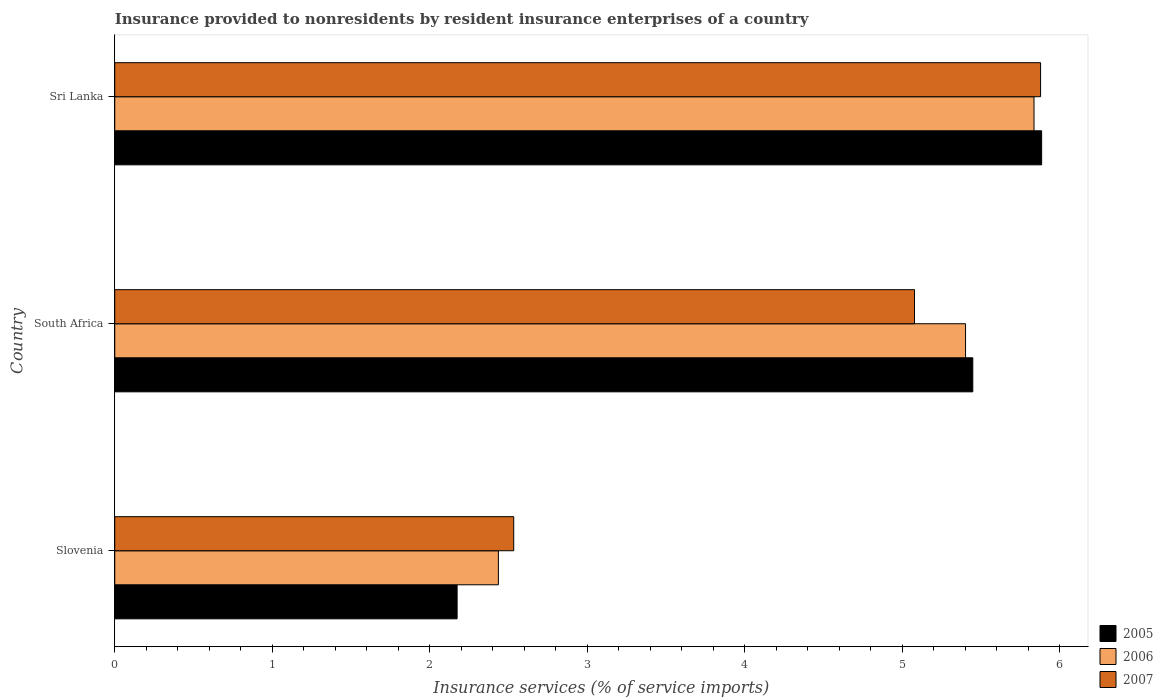How many different coloured bars are there?
Offer a very short reply. 3. Are the number of bars on each tick of the Y-axis equal?
Your answer should be compact. Yes. How many bars are there on the 2nd tick from the top?
Ensure brevity in your answer.  3. What is the label of the 1st group of bars from the top?
Offer a very short reply. Sri Lanka. In how many cases, is the number of bars for a given country not equal to the number of legend labels?
Give a very brief answer. 0. What is the insurance provided to nonresidents in 2005 in Slovenia?
Your response must be concise. 2.17. Across all countries, what is the maximum insurance provided to nonresidents in 2005?
Ensure brevity in your answer.  5.89. Across all countries, what is the minimum insurance provided to nonresidents in 2005?
Provide a succinct answer. 2.17. In which country was the insurance provided to nonresidents in 2006 maximum?
Your answer should be very brief. Sri Lanka. In which country was the insurance provided to nonresidents in 2006 minimum?
Provide a short and direct response. Slovenia. What is the total insurance provided to nonresidents in 2006 in the graph?
Your response must be concise. 13.68. What is the difference between the insurance provided to nonresidents in 2005 in Slovenia and that in South Africa?
Give a very brief answer. -3.27. What is the difference between the insurance provided to nonresidents in 2005 in Sri Lanka and the insurance provided to nonresidents in 2007 in South Africa?
Your response must be concise. 0.81. What is the average insurance provided to nonresidents in 2007 per country?
Your answer should be compact. 4.5. What is the difference between the insurance provided to nonresidents in 2005 and insurance provided to nonresidents in 2007 in South Africa?
Your response must be concise. 0.37. In how many countries, is the insurance provided to nonresidents in 2005 greater than 3.4 %?
Offer a terse response. 2. What is the ratio of the insurance provided to nonresidents in 2006 in Slovenia to that in South Africa?
Provide a short and direct response. 0.45. Is the difference between the insurance provided to nonresidents in 2005 in Slovenia and South Africa greater than the difference between the insurance provided to nonresidents in 2007 in Slovenia and South Africa?
Offer a terse response. No. What is the difference between the highest and the second highest insurance provided to nonresidents in 2005?
Your answer should be compact. 0.44. What is the difference between the highest and the lowest insurance provided to nonresidents in 2005?
Your answer should be very brief. 3.71. What does the 1st bar from the bottom in Slovenia represents?
Provide a succinct answer. 2005. Is it the case that in every country, the sum of the insurance provided to nonresidents in 2006 and insurance provided to nonresidents in 2007 is greater than the insurance provided to nonresidents in 2005?
Provide a succinct answer. Yes. How many bars are there?
Make the answer very short. 9. How many countries are there in the graph?
Your answer should be compact. 3. What is the difference between two consecutive major ticks on the X-axis?
Give a very brief answer. 1. Are the values on the major ticks of X-axis written in scientific E-notation?
Offer a terse response. No. How are the legend labels stacked?
Provide a succinct answer. Vertical. What is the title of the graph?
Your response must be concise. Insurance provided to nonresidents by resident insurance enterprises of a country. Does "1988" appear as one of the legend labels in the graph?
Keep it short and to the point. No. What is the label or title of the X-axis?
Your response must be concise. Insurance services (% of service imports). What is the Insurance services (% of service imports) in 2005 in Slovenia?
Provide a short and direct response. 2.17. What is the Insurance services (% of service imports) of 2006 in Slovenia?
Offer a terse response. 2.44. What is the Insurance services (% of service imports) of 2007 in Slovenia?
Ensure brevity in your answer.  2.53. What is the Insurance services (% of service imports) of 2005 in South Africa?
Your answer should be very brief. 5.45. What is the Insurance services (% of service imports) in 2006 in South Africa?
Offer a very short reply. 5.4. What is the Insurance services (% of service imports) of 2007 in South Africa?
Your answer should be very brief. 5.08. What is the Insurance services (% of service imports) of 2005 in Sri Lanka?
Make the answer very short. 5.89. What is the Insurance services (% of service imports) of 2006 in Sri Lanka?
Give a very brief answer. 5.84. What is the Insurance services (% of service imports) in 2007 in Sri Lanka?
Give a very brief answer. 5.88. Across all countries, what is the maximum Insurance services (% of service imports) in 2005?
Your response must be concise. 5.89. Across all countries, what is the maximum Insurance services (% of service imports) of 2006?
Your answer should be compact. 5.84. Across all countries, what is the maximum Insurance services (% of service imports) of 2007?
Give a very brief answer. 5.88. Across all countries, what is the minimum Insurance services (% of service imports) of 2005?
Make the answer very short. 2.17. Across all countries, what is the minimum Insurance services (% of service imports) of 2006?
Provide a short and direct response. 2.44. Across all countries, what is the minimum Insurance services (% of service imports) in 2007?
Ensure brevity in your answer.  2.53. What is the total Insurance services (% of service imports) in 2005 in the graph?
Keep it short and to the point. 13.51. What is the total Insurance services (% of service imports) of 2006 in the graph?
Your response must be concise. 13.68. What is the total Insurance services (% of service imports) in 2007 in the graph?
Keep it short and to the point. 13.49. What is the difference between the Insurance services (% of service imports) of 2005 in Slovenia and that in South Africa?
Offer a terse response. -3.27. What is the difference between the Insurance services (% of service imports) in 2006 in Slovenia and that in South Africa?
Offer a terse response. -2.97. What is the difference between the Insurance services (% of service imports) in 2007 in Slovenia and that in South Africa?
Give a very brief answer. -2.55. What is the difference between the Insurance services (% of service imports) of 2005 in Slovenia and that in Sri Lanka?
Keep it short and to the point. -3.71. What is the difference between the Insurance services (% of service imports) of 2006 in Slovenia and that in Sri Lanka?
Your answer should be very brief. -3.4. What is the difference between the Insurance services (% of service imports) in 2007 in Slovenia and that in Sri Lanka?
Offer a very short reply. -3.35. What is the difference between the Insurance services (% of service imports) in 2005 in South Africa and that in Sri Lanka?
Give a very brief answer. -0.44. What is the difference between the Insurance services (% of service imports) of 2006 in South Africa and that in Sri Lanka?
Your answer should be very brief. -0.43. What is the difference between the Insurance services (% of service imports) of 2007 in South Africa and that in Sri Lanka?
Your answer should be very brief. -0.8. What is the difference between the Insurance services (% of service imports) of 2005 in Slovenia and the Insurance services (% of service imports) of 2006 in South Africa?
Ensure brevity in your answer.  -3.23. What is the difference between the Insurance services (% of service imports) in 2005 in Slovenia and the Insurance services (% of service imports) in 2007 in South Africa?
Your response must be concise. -2.9. What is the difference between the Insurance services (% of service imports) in 2006 in Slovenia and the Insurance services (% of service imports) in 2007 in South Africa?
Offer a terse response. -2.64. What is the difference between the Insurance services (% of service imports) of 2005 in Slovenia and the Insurance services (% of service imports) of 2006 in Sri Lanka?
Make the answer very short. -3.66. What is the difference between the Insurance services (% of service imports) in 2005 in Slovenia and the Insurance services (% of service imports) in 2007 in Sri Lanka?
Keep it short and to the point. -3.71. What is the difference between the Insurance services (% of service imports) of 2006 in Slovenia and the Insurance services (% of service imports) of 2007 in Sri Lanka?
Your answer should be compact. -3.44. What is the difference between the Insurance services (% of service imports) of 2005 in South Africa and the Insurance services (% of service imports) of 2006 in Sri Lanka?
Offer a very short reply. -0.39. What is the difference between the Insurance services (% of service imports) of 2005 in South Africa and the Insurance services (% of service imports) of 2007 in Sri Lanka?
Keep it short and to the point. -0.43. What is the difference between the Insurance services (% of service imports) of 2006 in South Africa and the Insurance services (% of service imports) of 2007 in Sri Lanka?
Offer a very short reply. -0.48. What is the average Insurance services (% of service imports) in 2005 per country?
Ensure brevity in your answer.  4.5. What is the average Insurance services (% of service imports) in 2006 per country?
Make the answer very short. 4.56. What is the average Insurance services (% of service imports) of 2007 per country?
Offer a terse response. 4.5. What is the difference between the Insurance services (% of service imports) of 2005 and Insurance services (% of service imports) of 2006 in Slovenia?
Your answer should be very brief. -0.26. What is the difference between the Insurance services (% of service imports) of 2005 and Insurance services (% of service imports) of 2007 in Slovenia?
Offer a very short reply. -0.36. What is the difference between the Insurance services (% of service imports) in 2006 and Insurance services (% of service imports) in 2007 in Slovenia?
Your answer should be very brief. -0.1. What is the difference between the Insurance services (% of service imports) of 2005 and Insurance services (% of service imports) of 2006 in South Africa?
Provide a short and direct response. 0.05. What is the difference between the Insurance services (% of service imports) of 2005 and Insurance services (% of service imports) of 2007 in South Africa?
Ensure brevity in your answer.  0.37. What is the difference between the Insurance services (% of service imports) in 2006 and Insurance services (% of service imports) in 2007 in South Africa?
Your response must be concise. 0.32. What is the difference between the Insurance services (% of service imports) of 2005 and Insurance services (% of service imports) of 2006 in Sri Lanka?
Offer a very short reply. 0.05. What is the difference between the Insurance services (% of service imports) of 2005 and Insurance services (% of service imports) of 2007 in Sri Lanka?
Your response must be concise. 0.01. What is the difference between the Insurance services (% of service imports) of 2006 and Insurance services (% of service imports) of 2007 in Sri Lanka?
Ensure brevity in your answer.  -0.04. What is the ratio of the Insurance services (% of service imports) in 2005 in Slovenia to that in South Africa?
Your response must be concise. 0.4. What is the ratio of the Insurance services (% of service imports) in 2006 in Slovenia to that in South Africa?
Keep it short and to the point. 0.45. What is the ratio of the Insurance services (% of service imports) in 2007 in Slovenia to that in South Africa?
Your answer should be compact. 0.5. What is the ratio of the Insurance services (% of service imports) of 2005 in Slovenia to that in Sri Lanka?
Your answer should be compact. 0.37. What is the ratio of the Insurance services (% of service imports) in 2006 in Slovenia to that in Sri Lanka?
Ensure brevity in your answer.  0.42. What is the ratio of the Insurance services (% of service imports) in 2007 in Slovenia to that in Sri Lanka?
Your answer should be compact. 0.43. What is the ratio of the Insurance services (% of service imports) of 2005 in South Africa to that in Sri Lanka?
Your answer should be compact. 0.93. What is the ratio of the Insurance services (% of service imports) of 2006 in South Africa to that in Sri Lanka?
Give a very brief answer. 0.93. What is the ratio of the Insurance services (% of service imports) of 2007 in South Africa to that in Sri Lanka?
Ensure brevity in your answer.  0.86. What is the difference between the highest and the second highest Insurance services (% of service imports) of 2005?
Your answer should be compact. 0.44. What is the difference between the highest and the second highest Insurance services (% of service imports) in 2006?
Keep it short and to the point. 0.43. What is the difference between the highest and the second highest Insurance services (% of service imports) in 2007?
Give a very brief answer. 0.8. What is the difference between the highest and the lowest Insurance services (% of service imports) in 2005?
Give a very brief answer. 3.71. What is the difference between the highest and the lowest Insurance services (% of service imports) of 2006?
Provide a short and direct response. 3.4. What is the difference between the highest and the lowest Insurance services (% of service imports) of 2007?
Your response must be concise. 3.35. 